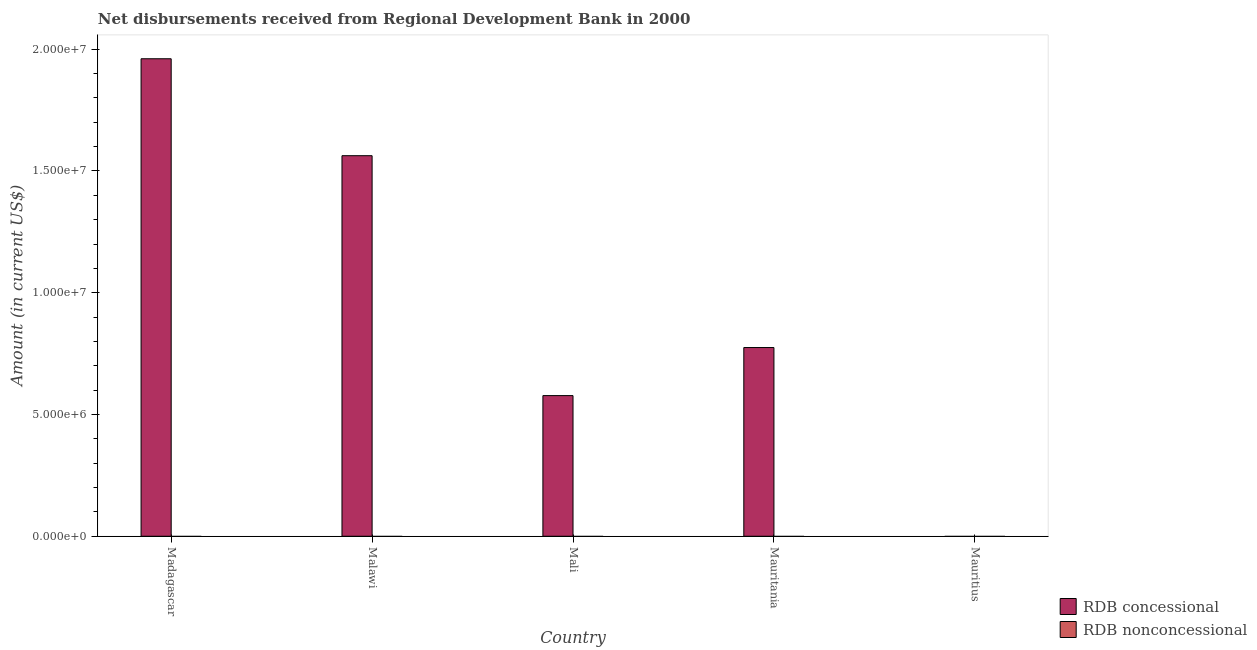How many different coloured bars are there?
Make the answer very short. 1. Are the number of bars per tick equal to the number of legend labels?
Give a very brief answer. No. How many bars are there on the 2nd tick from the right?
Ensure brevity in your answer.  1. What is the label of the 2nd group of bars from the left?
Provide a short and direct response. Malawi. In how many cases, is the number of bars for a given country not equal to the number of legend labels?
Offer a terse response. 5. What is the net concessional disbursements from rdb in Mauritania?
Provide a short and direct response. 7.75e+06. Across all countries, what is the maximum net concessional disbursements from rdb?
Give a very brief answer. 1.96e+07. Across all countries, what is the minimum net concessional disbursements from rdb?
Your response must be concise. 0. In which country was the net concessional disbursements from rdb maximum?
Keep it short and to the point. Madagascar. What is the total net concessional disbursements from rdb in the graph?
Offer a very short reply. 4.88e+07. What is the difference between the net concessional disbursements from rdb in Madagascar and that in Malawi?
Your response must be concise. 3.98e+06. What is the difference between the net non concessional disbursements from rdb in Mauritania and the net concessional disbursements from rdb in Mali?
Offer a very short reply. -5.78e+06. What is the average net concessional disbursements from rdb per country?
Offer a very short reply. 9.75e+06. What is the ratio of the net concessional disbursements from rdb in Malawi to that in Mauritania?
Your answer should be very brief. 2.02. What is the difference between the highest and the second highest net concessional disbursements from rdb?
Offer a very short reply. 3.98e+06. What is the difference between the highest and the lowest net concessional disbursements from rdb?
Your answer should be compact. 1.96e+07. In how many countries, is the net concessional disbursements from rdb greater than the average net concessional disbursements from rdb taken over all countries?
Provide a succinct answer. 2. Are all the bars in the graph horizontal?
Ensure brevity in your answer.  No. How many countries are there in the graph?
Your response must be concise. 5. Are the values on the major ticks of Y-axis written in scientific E-notation?
Your response must be concise. Yes. Does the graph contain any zero values?
Provide a short and direct response. Yes. What is the title of the graph?
Offer a terse response. Net disbursements received from Regional Development Bank in 2000. Does "Nitrous oxide" appear as one of the legend labels in the graph?
Offer a terse response. No. What is the label or title of the X-axis?
Provide a short and direct response. Country. What is the Amount (in current US$) of RDB concessional in Madagascar?
Your answer should be very brief. 1.96e+07. What is the Amount (in current US$) in RDB concessional in Malawi?
Offer a very short reply. 1.56e+07. What is the Amount (in current US$) in RDB nonconcessional in Malawi?
Offer a terse response. 0. What is the Amount (in current US$) in RDB concessional in Mali?
Offer a terse response. 5.78e+06. What is the Amount (in current US$) in RDB concessional in Mauritania?
Your answer should be compact. 7.75e+06. Across all countries, what is the maximum Amount (in current US$) of RDB concessional?
Offer a terse response. 1.96e+07. Across all countries, what is the minimum Amount (in current US$) of RDB concessional?
Ensure brevity in your answer.  0. What is the total Amount (in current US$) in RDB concessional in the graph?
Your response must be concise. 4.88e+07. What is the difference between the Amount (in current US$) of RDB concessional in Madagascar and that in Malawi?
Keep it short and to the point. 3.98e+06. What is the difference between the Amount (in current US$) of RDB concessional in Madagascar and that in Mali?
Ensure brevity in your answer.  1.38e+07. What is the difference between the Amount (in current US$) in RDB concessional in Madagascar and that in Mauritania?
Offer a terse response. 1.19e+07. What is the difference between the Amount (in current US$) of RDB concessional in Malawi and that in Mali?
Offer a very short reply. 9.85e+06. What is the difference between the Amount (in current US$) of RDB concessional in Malawi and that in Mauritania?
Give a very brief answer. 7.88e+06. What is the difference between the Amount (in current US$) in RDB concessional in Mali and that in Mauritania?
Offer a very short reply. -1.97e+06. What is the average Amount (in current US$) in RDB concessional per country?
Keep it short and to the point. 9.75e+06. What is the average Amount (in current US$) in RDB nonconcessional per country?
Your response must be concise. 0. What is the ratio of the Amount (in current US$) in RDB concessional in Madagascar to that in Malawi?
Provide a short and direct response. 1.25. What is the ratio of the Amount (in current US$) of RDB concessional in Madagascar to that in Mali?
Make the answer very short. 3.4. What is the ratio of the Amount (in current US$) of RDB concessional in Madagascar to that in Mauritania?
Ensure brevity in your answer.  2.53. What is the ratio of the Amount (in current US$) of RDB concessional in Malawi to that in Mali?
Your answer should be compact. 2.71. What is the ratio of the Amount (in current US$) in RDB concessional in Malawi to that in Mauritania?
Your response must be concise. 2.02. What is the ratio of the Amount (in current US$) in RDB concessional in Mali to that in Mauritania?
Keep it short and to the point. 0.75. What is the difference between the highest and the second highest Amount (in current US$) in RDB concessional?
Provide a succinct answer. 3.98e+06. What is the difference between the highest and the lowest Amount (in current US$) in RDB concessional?
Your answer should be very brief. 1.96e+07. 